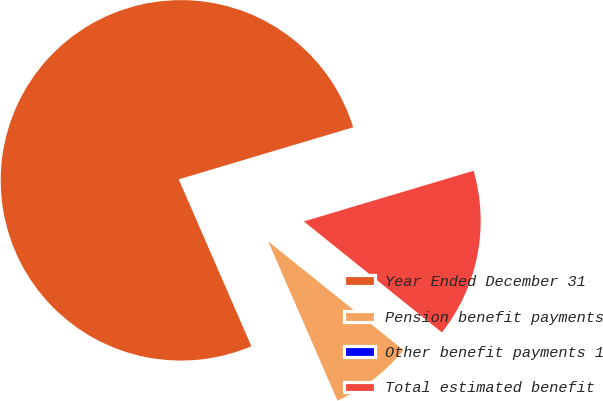Convert chart. <chart><loc_0><loc_0><loc_500><loc_500><pie_chart><fcel>Year Ended December 31<fcel>Pension benefit payments<fcel>Other benefit payments 1<fcel>Total estimated benefit<nl><fcel>76.92%<fcel>7.69%<fcel>0.0%<fcel>15.39%<nl></chart> 